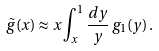Convert formula to latex. <formula><loc_0><loc_0><loc_500><loc_500>\tilde { g } ( x ) \approx x \int _ { x } ^ { 1 } \frac { d y } { y } \, g _ { 1 } ( y ) \, .</formula> 